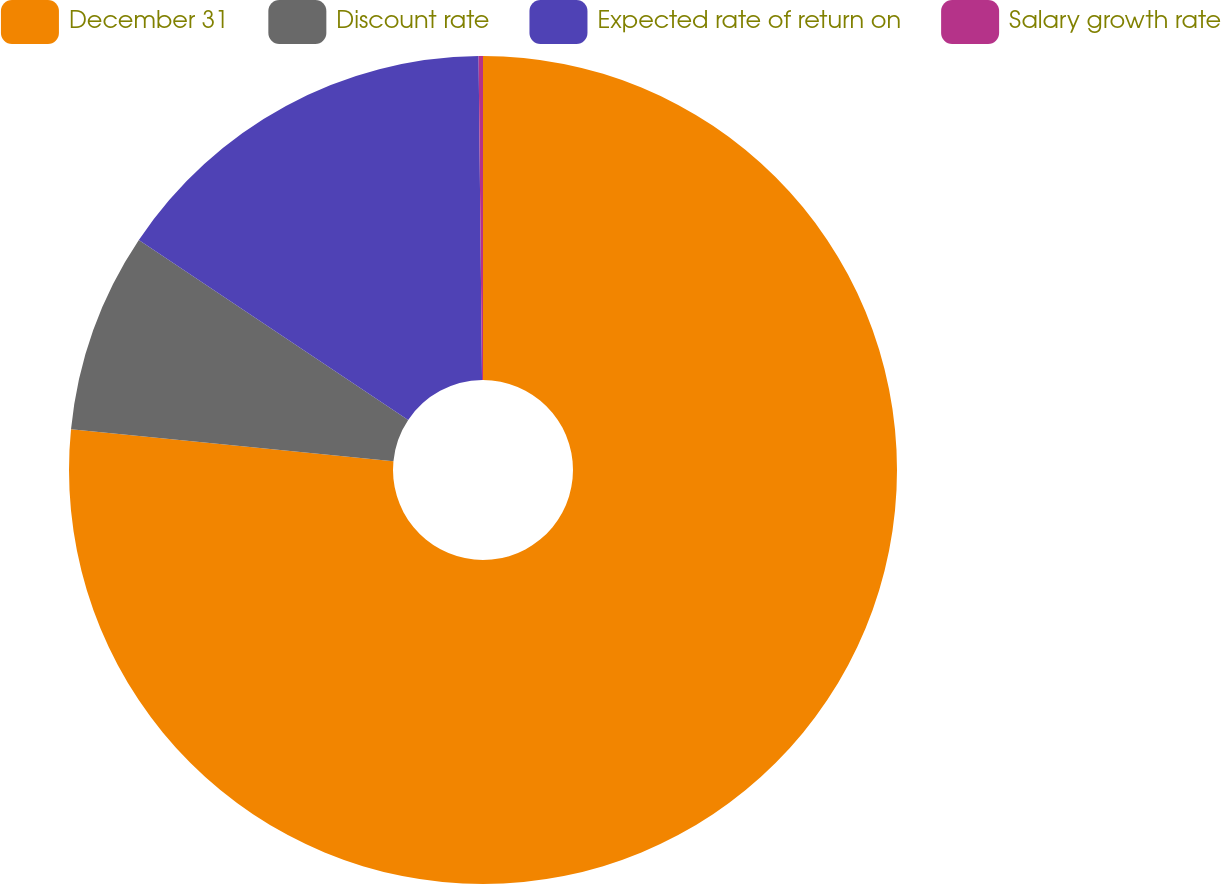Convert chart. <chart><loc_0><loc_0><loc_500><loc_500><pie_chart><fcel>December 31<fcel>Discount rate<fcel>Expected rate of return on<fcel>Salary growth rate<nl><fcel>76.57%<fcel>7.81%<fcel>15.45%<fcel>0.17%<nl></chart> 